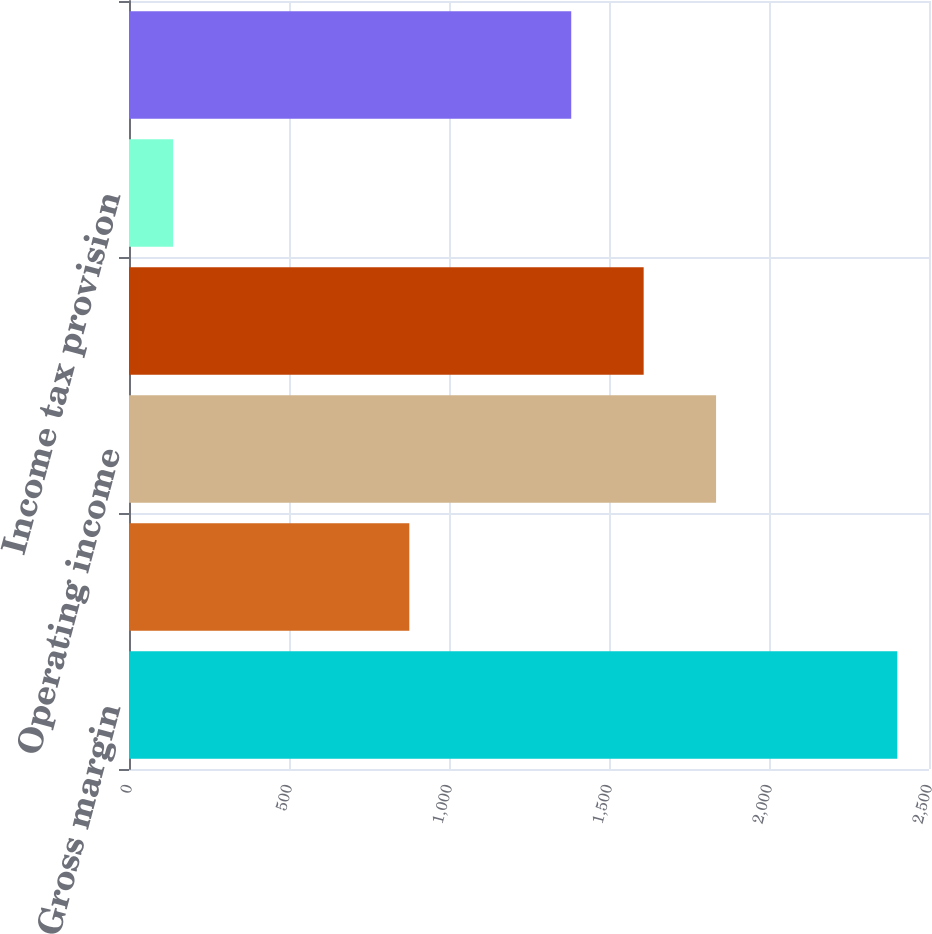Convert chart. <chart><loc_0><loc_0><loc_500><loc_500><bar_chart><fcel>Gross margin<fcel>R&D and SG&A<fcel>Operating income<fcel>Income before income taxes<fcel>Income tax provision<fcel>Net income<nl><fcel>2401<fcel>876<fcel>1834.6<fcel>1608.3<fcel>138<fcel>1382<nl></chart> 